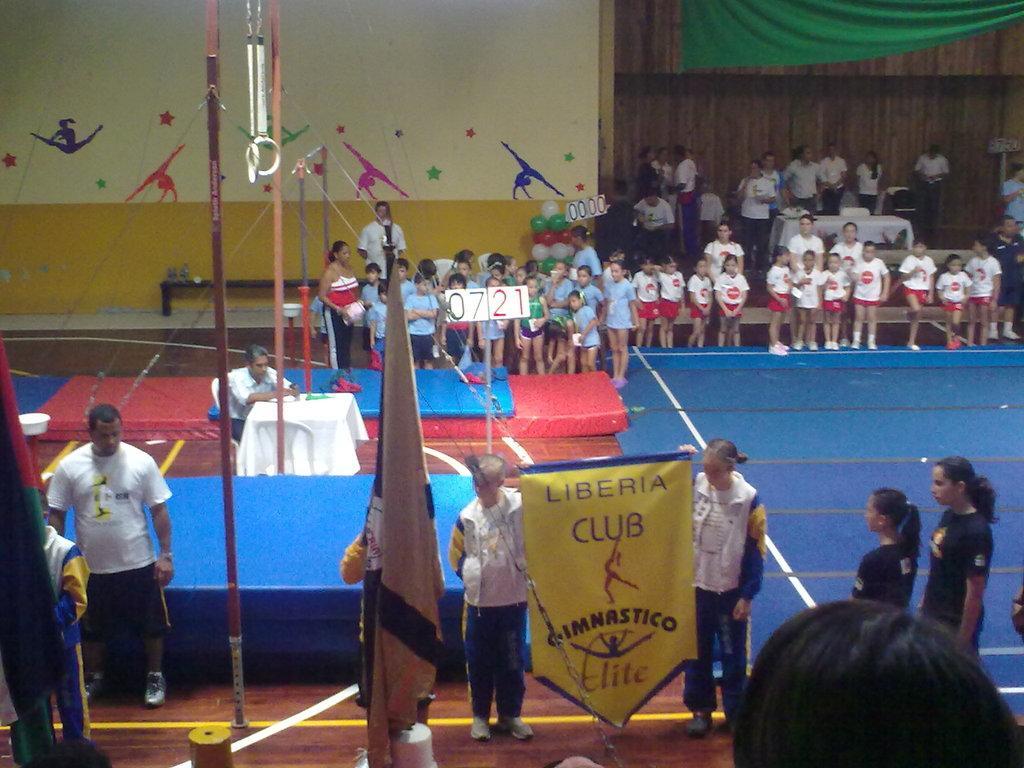How would you summarize this image in a sentence or two? This is the picture of a place where we have some kids, among them two are holding the poster and around there are some other people, tables and some painting to the wall. 